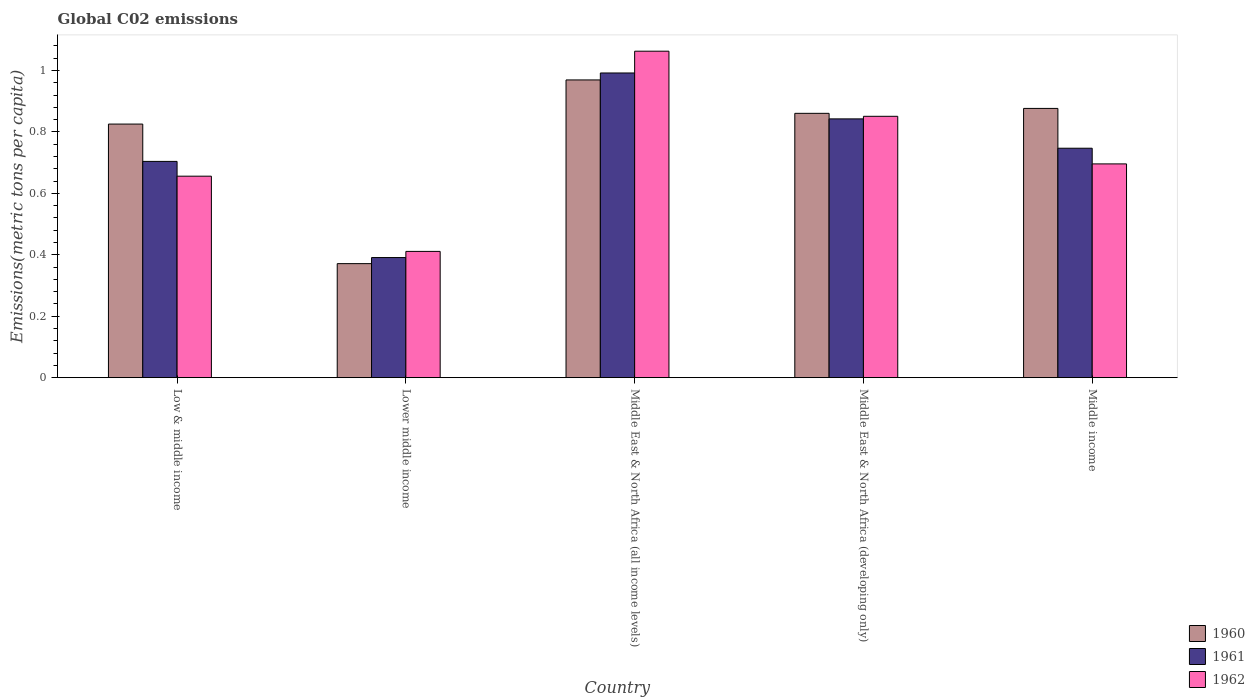How many different coloured bars are there?
Your response must be concise. 3. How many groups of bars are there?
Ensure brevity in your answer.  5. Are the number of bars on each tick of the X-axis equal?
Offer a terse response. Yes. How many bars are there on the 1st tick from the right?
Your answer should be compact. 3. What is the label of the 3rd group of bars from the left?
Your response must be concise. Middle East & North Africa (all income levels). In how many cases, is the number of bars for a given country not equal to the number of legend labels?
Ensure brevity in your answer.  0. What is the amount of CO2 emitted in in 1960 in Middle East & North Africa (all income levels)?
Ensure brevity in your answer.  0.97. Across all countries, what is the maximum amount of CO2 emitted in in 1962?
Your answer should be compact. 1.06. Across all countries, what is the minimum amount of CO2 emitted in in 1962?
Offer a very short reply. 0.41. In which country was the amount of CO2 emitted in in 1961 maximum?
Ensure brevity in your answer.  Middle East & North Africa (all income levels). In which country was the amount of CO2 emitted in in 1962 minimum?
Your answer should be compact. Lower middle income. What is the total amount of CO2 emitted in in 1961 in the graph?
Your response must be concise. 3.68. What is the difference between the amount of CO2 emitted in in 1960 in Low & middle income and that in Middle East & North Africa (developing only)?
Offer a terse response. -0.03. What is the difference between the amount of CO2 emitted in in 1962 in Low & middle income and the amount of CO2 emitted in in 1960 in Middle East & North Africa (developing only)?
Your response must be concise. -0.2. What is the average amount of CO2 emitted in in 1962 per country?
Offer a terse response. 0.74. What is the difference between the amount of CO2 emitted in of/in 1961 and amount of CO2 emitted in of/in 1962 in Middle East & North Africa (developing only)?
Provide a succinct answer. -0.01. In how many countries, is the amount of CO2 emitted in in 1960 greater than 0.4 metric tons per capita?
Give a very brief answer. 4. What is the ratio of the amount of CO2 emitted in in 1961 in Middle East & North Africa (developing only) to that in Middle income?
Ensure brevity in your answer.  1.13. Is the amount of CO2 emitted in in 1962 in Lower middle income less than that in Middle East & North Africa (developing only)?
Offer a terse response. Yes. Is the difference between the amount of CO2 emitted in in 1961 in Low & middle income and Lower middle income greater than the difference between the amount of CO2 emitted in in 1962 in Low & middle income and Lower middle income?
Your answer should be very brief. Yes. What is the difference between the highest and the second highest amount of CO2 emitted in in 1962?
Ensure brevity in your answer.  -0.21. What is the difference between the highest and the lowest amount of CO2 emitted in in 1962?
Ensure brevity in your answer.  0.65. Is the sum of the amount of CO2 emitted in in 1962 in Low & middle income and Middle East & North Africa (all income levels) greater than the maximum amount of CO2 emitted in in 1960 across all countries?
Keep it short and to the point. Yes. What does the 3rd bar from the left in Middle income represents?
Offer a terse response. 1962. What does the 2nd bar from the right in Middle income represents?
Your answer should be very brief. 1961. How many countries are there in the graph?
Give a very brief answer. 5. Are the values on the major ticks of Y-axis written in scientific E-notation?
Your answer should be compact. No. Does the graph contain grids?
Provide a short and direct response. No. Where does the legend appear in the graph?
Provide a succinct answer. Bottom right. What is the title of the graph?
Provide a short and direct response. Global C02 emissions. Does "2007" appear as one of the legend labels in the graph?
Keep it short and to the point. No. What is the label or title of the Y-axis?
Your response must be concise. Emissions(metric tons per capita). What is the Emissions(metric tons per capita) in 1960 in Low & middle income?
Provide a short and direct response. 0.83. What is the Emissions(metric tons per capita) of 1961 in Low & middle income?
Make the answer very short. 0.7. What is the Emissions(metric tons per capita) of 1962 in Low & middle income?
Your answer should be very brief. 0.66. What is the Emissions(metric tons per capita) in 1960 in Lower middle income?
Ensure brevity in your answer.  0.37. What is the Emissions(metric tons per capita) in 1961 in Lower middle income?
Your response must be concise. 0.39. What is the Emissions(metric tons per capita) of 1962 in Lower middle income?
Your response must be concise. 0.41. What is the Emissions(metric tons per capita) in 1960 in Middle East & North Africa (all income levels)?
Make the answer very short. 0.97. What is the Emissions(metric tons per capita) in 1961 in Middle East & North Africa (all income levels)?
Your answer should be compact. 0.99. What is the Emissions(metric tons per capita) of 1962 in Middle East & North Africa (all income levels)?
Provide a short and direct response. 1.06. What is the Emissions(metric tons per capita) in 1960 in Middle East & North Africa (developing only)?
Make the answer very short. 0.86. What is the Emissions(metric tons per capita) of 1961 in Middle East & North Africa (developing only)?
Offer a very short reply. 0.84. What is the Emissions(metric tons per capita) of 1962 in Middle East & North Africa (developing only)?
Ensure brevity in your answer.  0.85. What is the Emissions(metric tons per capita) in 1960 in Middle income?
Provide a short and direct response. 0.88. What is the Emissions(metric tons per capita) in 1961 in Middle income?
Make the answer very short. 0.75. What is the Emissions(metric tons per capita) in 1962 in Middle income?
Keep it short and to the point. 0.7. Across all countries, what is the maximum Emissions(metric tons per capita) of 1960?
Your answer should be very brief. 0.97. Across all countries, what is the maximum Emissions(metric tons per capita) in 1961?
Ensure brevity in your answer.  0.99. Across all countries, what is the maximum Emissions(metric tons per capita) in 1962?
Your answer should be very brief. 1.06. Across all countries, what is the minimum Emissions(metric tons per capita) in 1960?
Your response must be concise. 0.37. Across all countries, what is the minimum Emissions(metric tons per capita) in 1961?
Provide a succinct answer. 0.39. Across all countries, what is the minimum Emissions(metric tons per capita) of 1962?
Your answer should be compact. 0.41. What is the total Emissions(metric tons per capita) of 1960 in the graph?
Offer a terse response. 3.9. What is the total Emissions(metric tons per capita) of 1961 in the graph?
Give a very brief answer. 3.68. What is the total Emissions(metric tons per capita) in 1962 in the graph?
Provide a short and direct response. 3.68. What is the difference between the Emissions(metric tons per capita) of 1960 in Low & middle income and that in Lower middle income?
Give a very brief answer. 0.45. What is the difference between the Emissions(metric tons per capita) in 1961 in Low & middle income and that in Lower middle income?
Offer a terse response. 0.31. What is the difference between the Emissions(metric tons per capita) in 1962 in Low & middle income and that in Lower middle income?
Provide a short and direct response. 0.24. What is the difference between the Emissions(metric tons per capita) of 1960 in Low & middle income and that in Middle East & North Africa (all income levels)?
Offer a very short reply. -0.14. What is the difference between the Emissions(metric tons per capita) of 1961 in Low & middle income and that in Middle East & North Africa (all income levels)?
Give a very brief answer. -0.29. What is the difference between the Emissions(metric tons per capita) of 1962 in Low & middle income and that in Middle East & North Africa (all income levels)?
Ensure brevity in your answer.  -0.41. What is the difference between the Emissions(metric tons per capita) of 1960 in Low & middle income and that in Middle East & North Africa (developing only)?
Your answer should be very brief. -0.04. What is the difference between the Emissions(metric tons per capita) of 1961 in Low & middle income and that in Middle East & North Africa (developing only)?
Your answer should be compact. -0.14. What is the difference between the Emissions(metric tons per capita) in 1962 in Low & middle income and that in Middle East & North Africa (developing only)?
Offer a terse response. -0.19. What is the difference between the Emissions(metric tons per capita) of 1960 in Low & middle income and that in Middle income?
Offer a terse response. -0.05. What is the difference between the Emissions(metric tons per capita) in 1961 in Low & middle income and that in Middle income?
Ensure brevity in your answer.  -0.04. What is the difference between the Emissions(metric tons per capita) in 1962 in Low & middle income and that in Middle income?
Provide a succinct answer. -0.04. What is the difference between the Emissions(metric tons per capita) in 1960 in Lower middle income and that in Middle East & North Africa (all income levels)?
Ensure brevity in your answer.  -0.6. What is the difference between the Emissions(metric tons per capita) in 1961 in Lower middle income and that in Middle East & North Africa (all income levels)?
Your answer should be compact. -0.6. What is the difference between the Emissions(metric tons per capita) in 1962 in Lower middle income and that in Middle East & North Africa (all income levels)?
Give a very brief answer. -0.65. What is the difference between the Emissions(metric tons per capita) of 1960 in Lower middle income and that in Middle East & North Africa (developing only)?
Offer a very short reply. -0.49. What is the difference between the Emissions(metric tons per capita) of 1961 in Lower middle income and that in Middle East & North Africa (developing only)?
Your answer should be very brief. -0.45. What is the difference between the Emissions(metric tons per capita) of 1962 in Lower middle income and that in Middle East & North Africa (developing only)?
Provide a succinct answer. -0.44. What is the difference between the Emissions(metric tons per capita) in 1960 in Lower middle income and that in Middle income?
Your answer should be compact. -0.51. What is the difference between the Emissions(metric tons per capita) of 1961 in Lower middle income and that in Middle income?
Make the answer very short. -0.36. What is the difference between the Emissions(metric tons per capita) of 1962 in Lower middle income and that in Middle income?
Provide a short and direct response. -0.28. What is the difference between the Emissions(metric tons per capita) in 1960 in Middle East & North Africa (all income levels) and that in Middle East & North Africa (developing only)?
Provide a short and direct response. 0.11. What is the difference between the Emissions(metric tons per capita) in 1961 in Middle East & North Africa (all income levels) and that in Middle East & North Africa (developing only)?
Provide a succinct answer. 0.15. What is the difference between the Emissions(metric tons per capita) of 1962 in Middle East & North Africa (all income levels) and that in Middle East & North Africa (developing only)?
Make the answer very short. 0.21. What is the difference between the Emissions(metric tons per capita) in 1960 in Middle East & North Africa (all income levels) and that in Middle income?
Provide a succinct answer. 0.09. What is the difference between the Emissions(metric tons per capita) of 1961 in Middle East & North Africa (all income levels) and that in Middle income?
Give a very brief answer. 0.24. What is the difference between the Emissions(metric tons per capita) of 1962 in Middle East & North Africa (all income levels) and that in Middle income?
Ensure brevity in your answer.  0.37. What is the difference between the Emissions(metric tons per capita) in 1960 in Middle East & North Africa (developing only) and that in Middle income?
Keep it short and to the point. -0.02. What is the difference between the Emissions(metric tons per capita) in 1961 in Middle East & North Africa (developing only) and that in Middle income?
Your answer should be compact. 0.1. What is the difference between the Emissions(metric tons per capita) of 1962 in Middle East & North Africa (developing only) and that in Middle income?
Offer a terse response. 0.15. What is the difference between the Emissions(metric tons per capita) of 1960 in Low & middle income and the Emissions(metric tons per capita) of 1961 in Lower middle income?
Your answer should be very brief. 0.43. What is the difference between the Emissions(metric tons per capita) in 1960 in Low & middle income and the Emissions(metric tons per capita) in 1962 in Lower middle income?
Keep it short and to the point. 0.41. What is the difference between the Emissions(metric tons per capita) in 1961 in Low & middle income and the Emissions(metric tons per capita) in 1962 in Lower middle income?
Ensure brevity in your answer.  0.29. What is the difference between the Emissions(metric tons per capita) of 1960 in Low & middle income and the Emissions(metric tons per capita) of 1961 in Middle East & North Africa (all income levels)?
Your response must be concise. -0.17. What is the difference between the Emissions(metric tons per capita) in 1960 in Low & middle income and the Emissions(metric tons per capita) in 1962 in Middle East & North Africa (all income levels)?
Provide a succinct answer. -0.24. What is the difference between the Emissions(metric tons per capita) of 1961 in Low & middle income and the Emissions(metric tons per capita) of 1962 in Middle East & North Africa (all income levels)?
Provide a short and direct response. -0.36. What is the difference between the Emissions(metric tons per capita) of 1960 in Low & middle income and the Emissions(metric tons per capita) of 1961 in Middle East & North Africa (developing only)?
Offer a very short reply. -0.02. What is the difference between the Emissions(metric tons per capita) of 1960 in Low & middle income and the Emissions(metric tons per capita) of 1962 in Middle East & North Africa (developing only)?
Keep it short and to the point. -0.03. What is the difference between the Emissions(metric tons per capita) of 1961 in Low & middle income and the Emissions(metric tons per capita) of 1962 in Middle East & North Africa (developing only)?
Provide a short and direct response. -0.15. What is the difference between the Emissions(metric tons per capita) of 1960 in Low & middle income and the Emissions(metric tons per capita) of 1961 in Middle income?
Make the answer very short. 0.08. What is the difference between the Emissions(metric tons per capita) in 1960 in Low & middle income and the Emissions(metric tons per capita) in 1962 in Middle income?
Offer a very short reply. 0.13. What is the difference between the Emissions(metric tons per capita) of 1961 in Low & middle income and the Emissions(metric tons per capita) of 1962 in Middle income?
Make the answer very short. 0.01. What is the difference between the Emissions(metric tons per capita) in 1960 in Lower middle income and the Emissions(metric tons per capita) in 1961 in Middle East & North Africa (all income levels)?
Make the answer very short. -0.62. What is the difference between the Emissions(metric tons per capita) in 1960 in Lower middle income and the Emissions(metric tons per capita) in 1962 in Middle East & North Africa (all income levels)?
Your response must be concise. -0.69. What is the difference between the Emissions(metric tons per capita) in 1961 in Lower middle income and the Emissions(metric tons per capita) in 1962 in Middle East & North Africa (all income levels)?
Provide a short and direct response. -0.67. What is the difference between the Emissions(metric tons per capita) of 1960 in Lower middle income and the Emissions(metric tons per capita) of 1961 in Middle East & North Africa (developing only)?
Ensure brevity in your answer.  -0.47. What is the difference between the Emissions(metric tons per capita) in 1960 in Lower middle income and the Emissions(metric tons per capita) in 1962 in Middle East & North Africa (developing only)?
Give a very brief answer. -0.48. What is the difference between the Emissions(metric tons per capita) in 1961 in Lower middle income and the Emissions(metric tons per capita) in 1962 in Middle East & North Africa (developing only)?
Keep it short and to the point. -0.46. What is the difference between the Emissions(metric tons per capita) in 1960 in Lower middle income and the Emissions(metric tons per capita) in 1961 in Middle income?
Your answer should be very brief. -0.38. What is the difference between the Emissions(metric tons per capita) of 1960 in Lower middle income and the Emissions(metric tons per capita) of 1962 in Middle income?
Your answer should be compact. -0.32. What is the difference between the Emissions(metric tons per capita) in 1961 in Lower middle income and the Emissions(metric tons per capita) in 1962 in Middle income?
Your answer should be compact. -0.3. What is the difference between the Emissions(metric tons per capita) in 1960 in Middle East & North Africa (all income levels) and the Emissions(metric tons per capita) in 1961 in Middle East & North Africa (developing only)?
Your answer should be compact. 0.13. What is the difference between the Emissions(metric tons per capita) in 1960 in Middle East & North Africa (all income levels) and the Emissions(metric tons per capita) in 1962 in Middle East & North Africa (developing only)?
Make the answer very short. 0.12. What is the difference between the Emissions(metric tons per capita) in 1961 in Middle East & North Africa (all income levels) and the Emissions(metric tons per capita) in 1962 in Middle East & North Africa (developing only)?
Your response must be concise. 0.14. What is the difference between the Emissions(metric tons per capita) in 1960 in Middle East & North Africa (all income levels) and the Emissions(metric tons per capita) in 1961 in Middle income?
Keep it short and to the point. 0.22. What is the difference between the Emissions(metric tons per capita) in 1960 in Middle East & North Africa (all income levels) and the Emissions(metric tons per capita) in 1962 in Middle income?
Make the answer very short. 0.27. What is the difference between the Emissions(metric tons per capita) of 1961 in Middle East & North Africa (all income levels) and the Emissions(metric tons per capita) of 1962 in Middle income?
Offer a terse response. 0.3. What is the difference between the Emissions(metric tons per capita) of 1960 in Middle East & North Africa (developing only) and the Emissions(metric tons per capita) of 1961 in Middle income?
Keep it short and to the point. 0.11. What is the difference between the Emissions(metric tons per capita) of 1960 in Middle East & North Africa (developing only) and the Emissions(metric tons per capita) of 1962 in Middle income?
Your response must be concise. 0.16. What is the difference between the Emissions(metric tons per capita) in 1961 in Middle East & North Africa (developing only) and the Emissions(metric tons per capita) in 1962 in Middle income?
Provide a short and direct response. 0.15. What is the average Emissions(metric tons per capita) of 1960 per country?
Provide a succinct answer. 0.78. What is the average Emissions(metric tons per capita) of 1961 per country?
Offer a terse response. 0.74. What is the average Emissions(metric tons per capita) of 1962 per country?
Give a very brief answer. 0.74. What is the difference between the Emissions(metric tons per capita) of 1960 and Emissions(metric tons per capita) of 1961 in Low & middle income?
Provide a short and direct response. 0.12. What is the difference between the Emissions(metric tons per capita) of 1960 and Emissions(metric tons per capita) of 1962 in Low & middle income?
Make the answer very short. 0.17. What is the difference between the Emissions(metric tons per capita) in 1961 and Emissions(metric tons per capita) in 1962 in Low & middle income?
Offer a very short reply. 0.05. What is the difference between the Emissions(metric tons per capita) in 1960 and Emissions(metric tons per capita) in 1961 in Lower middle income?
Provide a succinct answer. -0.02. What is the difference between the Emissions(metric tons per capita) in 1960 and Emissions(metric tons per capita) in 1962 in Lower middle income?
Your response must be concise. -0.04. What is the difference between the Emissions(metric tons per capita) in 1961 and Emissions(metric tons per capita) in 1962 in Lower middle income?
Provide a succinct answer. -0.02. What is the difference between the Emissions(metric tons per capita) of 1960 and Emissions(metric tons per capita) of 1961 in Middle East & North Africa (all income levels)?
Your answer should be very brief. -0.02. What is the difference between the Emissions(metric tons per capita) in 1960 and Emissions(metric tons per capita) in 1962 in Middle East & North Africa (all income levels)?
Provide a short and direct response. -0.09. What is the difference between the Emissions(metric tons per capita) in 1961 and Emissions(metric tons per capita) in 1962 in Middle East & North Africa (all income levels)?
Keep it short and to the point. -0.07. What is the difference between the Emissions(metric tons per capita) of 1960 and Emissions(metric tons per capita) of 1961 in Middle East & North Africa (developing only)?
Provide a succinct answer. 0.02. What is the difference between the Emissions(metric tons per capita) of 1960 and Emissions(metric tons per capita) of 1962 in Middle East & North Africa (developing only)?
Give a very brief answer. 0.01. What is the difference between the Emissions(metric tons per capita) in 1961 and Emissions(metric tons per capita) in 1962 in Middle East & North Africa (developing only)?
Provide a short and direct response. -0.01. What is the difference between the Emissions(metric tons per capita) of 1960 and Emissions(metric tons per capita) of 1961 in Middle income?
Ensure brevity in your answer.  0.13. What is the difference between the Emissions(metric tons per capita) in 1960 and Emissions(metric tons per capita) in 1962 in Middle income?
Offer a very short reply. 0.18. What is the difference between the Emissions(metric tons per capita) in 1961 and Emissions(metric tons per capita) in 1962 in Middle income?
Your response must be concise. 0.05. What is the ratio of the Emissions(metric tons per capita) of 1960 in Low & middle income to that in Lower middle income?
Offer a very short reply. 2.22. What is the ratio of the Emissions(metric tons per capita) of 1961 in Low & middle income to that in Lower middle income?
Your answer should be compact. 1.8. What is the ratio of the Emissions(metric tons per capita) in 1962 in Low & middle income to that in Lower middle income?
Keep it short and to the point. 1.6. What is the ratio of the Emissions(metric tons per capita) of 1960 in Low & middle income to that in Middle East & North Africa (all income levels)?
Provide a succinct answer. 0.85. What is the ratio of the Emissions(metric tons per capita) in 1961 in Low & middle income to that in Middle East & North Africa (all income levels)?
Ensure brevity in your answer.  0.71. What is the ratio of the Emissions(metric tons per capita) of 1962 in Low & middle income to that in Middle East & North Africa (all income levels)?
Your answer should be very brief. 0.62. What is the ratio of the Emissions(metric tons per capita) in 1960 in Low & middle income to that in Middle East & North Africa (developing only)?
Ensure brevity in your answer.  0.96. What is the ratio of the Emissions(metric tons per capita) of 1961 in Low & middle income to that in Middle East & North Africa (developing only)?
Offer a very short reply. 0.84. What is the ratio of the Emissions(metric tons per capita) in 1962 in Low & middle income to that in Middle East & North Africa (developing only)?
Provide a succinct answer. 0.77. What is the ratio of the Emissions(metric tons per capita) in 1960 in Low & middle income to that in Middle income?
Your answer should be compact. 0.94. What is the ratio of the Emissions(metric tons per capita) of 1961 in Low & middle income to that in Middle income?
Your answer should be very brief. 0.94. What is the ratio of the Emissions(metric tons per capita) in 1962 in Low & middle income to that in Middle income?
Keep it short and to the point. 0.94. What is the ratio of the Emissions(metric tons per capita) of 1960 in Lower middle income to that in Middle East & North Africa (all income levels)?
Offer a very short reply. 0.38. What is the ratio of the Emissions(metric tons per capita) in 1961 in Lower middle income to that in Middle East & North Africa (all income levels)?
Provide a short and direct response. 0.39. What is the ratio of the Emissions(metric tons per capita) in 1962 in Lower middle income to that in Middle East & North Africa (all income levels)?
Offer a very short reply. 0.39. What is the ratio of the Emissions(metric tons per capita) in 1960 in Lower middle income to that in Middle East & North Africa (developing only)?
Your answer should be compact. 0.43. What is the ratio of the Emissions(metric tons per capita) in 1961 in Lower middle income to that in Middle East & North Africa (developing only)?
Keep it short and to the point. 0.46. What is the ratio of the Emissions(metric tons per capita) in 1962 in Lower middle income to that in Middle East & North Africa (developing only)?
Ensure brevity in your answer.  0.48. What is the ratio of the Emissions(metric tons per capita) in 1960 in Lower middle income to that in Middle income?
Make the answer very short. 0.42. What is the ratio of the Emissions(metric tons per capita) in 1961 in Lower middle income to that in Middle income?
Provide a short and direct response. 0.52. What is the ratio of the Emissions(metric tons per capita) in 1962 in Lower middle income to that in Middle income?
Provide a succinct answer. 0.59. What is the ratio of the Emissions(metric tons per capita) in 1960 in Middle East & North Africa (all income levels) to that in Middle East & North Africa (developing only)?
Offer a terse response. 1.13. What is the ratio of the Emissions(metric tons per capita) in 1961 in Middle East & North Africa (all income levels) to that in Middle East & North Africa (developing only)?
Ensure brevity in your answer.  1.18. What is the ratio of the Emissions(metric tons per capita) in 1962 in Middle East & North Africa (all income levels) to that in Middle East & North Africa (developing only)?
Your response must be concise. 1.25. What is the ratio of the Emissions(metric tons per capita) of 1960 in Middle East & North Africa (all income levels) to that in Middle income?
Keep it short and to the point. 1.11. What is the ratio of the Emissions(metric tons per capita) of 1961 in Middle East & North Africa (all income levels) to that in Middle income?
Your answer should be compact. 1.33. What is the ratio of the Emissions(metric tons per capita) in 1962 in Middle East & North Africa (all income levels) to that in Middle income?
Ensure brevity in your answer.  1.53. What is the ratio of the Emissions(metric tons per capita) in 1960 in Middle East & North Africa (developing only) to that in Middle income?
Your response must be concise. 0.98. What is the ratio of the Emissions(metric tons per capita) of 1961 in Middle East & North Africa (developing only) to that in Middle income?
Ensure brevity in your answer.  1.13. What is the ratio of the Emissions(metric tons per capita) of 1962 in Middle East & North Africa (developing only) to that in Middle income?
Make the answer very short. 1.22. What is the difference between the highest and the second highest Emissions(metric tons per capita) in 1960?
Offer a very short reply. 0.09. What is the difference between the highest and the second highest Emissions(metric tons per capita) in 1961?
Your answer should be very brief. 0.15. What is the difference between the highest and the second highest Emissions(metric tons per capita) in 1962?
Give a very brief answer. 0.21. What is the difference between the highest and the lowest Emissions(metric tons per capita) of 1960?
Make the answer very short. 0.6. What is the difference between the highest and the lowest Emissions(metric tons per capita) of 1961?
Provide a short and direct response. 0.6. What is the difference between the highest and the lowest Emissions(metric tons per capita) in 1962?
Keep it short and to the point. 0.65. 